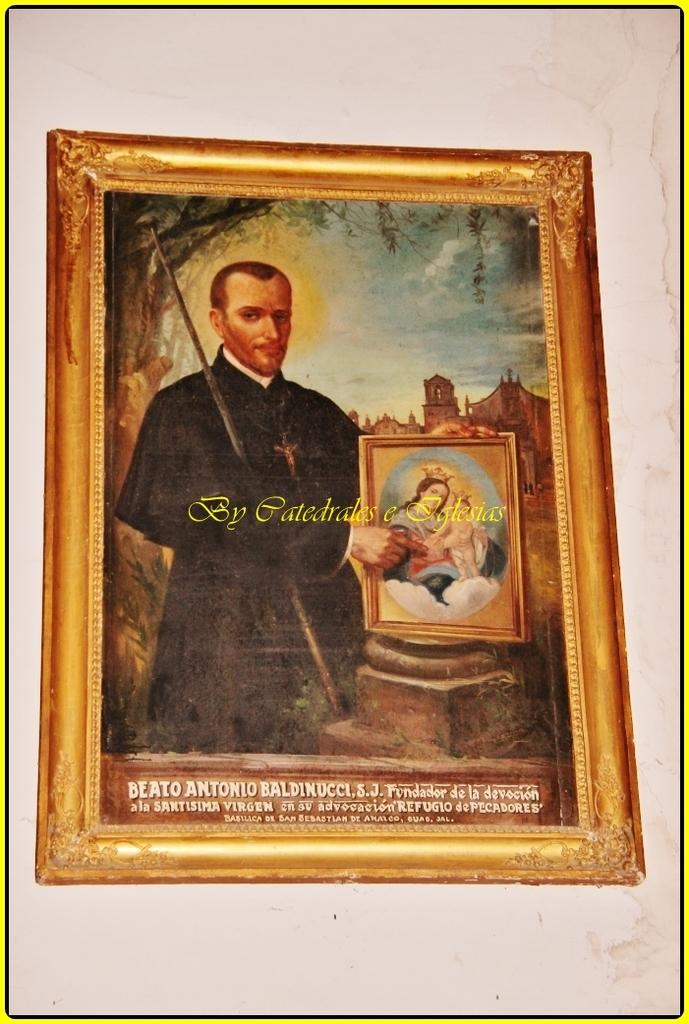<image>
Describe the image concisely. A painting has some text under it that starts with the word "Beato". 